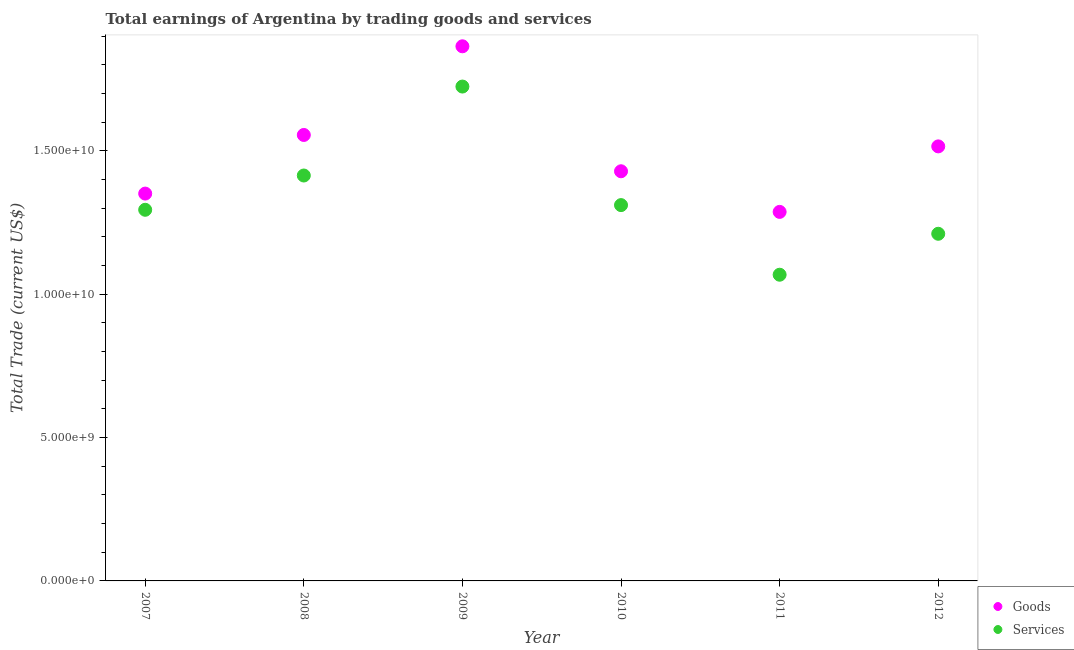How many different coloured dotlines are there?
Offer a very short reply. 2. Is the number of dotlines equal to the number of legend labels?
Offer a very short reply. Yes. What is the amount earned by trading goods in 2007?
Offer a terse response. 1.35e+1. Across all years, what is the maximum amount earned by trading goods?
Offer a terse response. 1.86e+1. Across all years, what is the minimum amount earned by trading services?
Provide a succinct answer. 1.07e+1. In which year was the amount earned by trading services maximum?
Make the answer very short. 2009. In which year was the amount earned by trading services minimum?
Ensure brevity in your answer.  2011. What is the total amount earned by trading goods in the graph?
Provide a succinct answer. 9.00e+1. What is the difference between the amount earned by trading goods in 2010 and that in 2012?
Provide a short and direct response. -8.68e+08. What is the difference between the amount earned by trading goods in 2012 and the amount earned by trading services in 2009?
Your answer should be very brief. -2.09e+09. What is the average amount earned by trading services per year?
Provide a succinct answer. 1.34e+1. In the year 2009, what is the difference between the amount earned by trading services and amount earned by trading goods?
Give a very brief answer. -1.40e+09. What is the ratio of the amount earned by trading services in 2008 to that in 2009?
Your answer should be very brief. 0.82. Is the difference between the amount earned by trading services in 2008 and 2009 greater than the difference between the amount earned by trading goods in 2008 and 2009?
Offer a very short reply. No. What is the difference between the highest and the second highest amount earned by trading services?
Ensure brevity in your answer.  3.10e+09. What is the difference between the highest and the lowest amount earned by trading goods?
Offer a terse response. 5.77e+09. Is the sum of the amount earned by trading services in 2010 and 2012 greater than the maximum amount earned by trading goods across all years?
Make the answer very short. Yes. Is the amount earned by trading goods strictly less than the amount earned by trading services over the years?
Your answer should be very brief. No. Are the values on the major ticks of Y-axis written in scientific E-notation?
Make the answer very short. Yes. Does the graph contain grids?
Your answer should be very brief. No. How many legend labels are there?
Give a very brief answer. 2. How are the legend labels stacked?
Ensure brevity in your answer.  Vertical. What is the title of the graph?
Provide a short and direct response. Total earnings of Argentina by trading goods and services. What is the label or title of the X-axis?
Give a very brief answer. Year. What is the label or title of the Y-axis?
Your response must be concise. Total Trade (current US$). What is the Total Trade (current US$) in Goods in 2007?
Offer a terse response. 1.35e+1. What is the Total Trade (current US$) in Services in 2007?
Your response must be concise. 1.29e+1. What is the Total Trade (current US$) in Goods in 2008?
Offer a terse response. 1.56e+1. What is the Total Trade (current US$) in Services in 2008?
Make the answer very short. 1.41e+1. What is the Total Trade (current US$) of Goods in 2009?
Offer a terse response. 1.86e+1. What is the Total Trade (current US$) of Services in 2009?
Give a very brief answer. 1.72e+1. What is the Total Trade (current US$) of Goods in 2010?
Your response must be concise. 1.43e+1. What is the Total Trade (current US$) of Services in 2010?
Keep it short and to the point. 1.31e+1. What is the Total Trade (current US$) of Goods in 2011?
Offer a terse response. 1.29e+1. What is the Total Trade (current US$) of Services in 2011?
Make the answer very short. 1.07e+1. What is the Total Trade (current US$) in Goods in 2012?
Keep it short and to the point. 1.52e+1. What is the Total Trade (current US$) of Services in 2012?
Your answer should be compact. 1.21e+1. Across all years, what is the maximum Total Trade (current US$) in Goods?
Make the answer very short. 1.86e+1. Across all years, what is the maximum Total Trade (current US$) in Services?
Make the answer very short. 1.72e+1. Across all years, what is the minimum Total Trade (current US$) in Goods?
Offer a terse response. 1.29e+1. Across all years, what is the minimum Total Trade (current US$) in Services?
Your answer should be compact. 1.07e+1. What is the total Total Trade (current US$) in Goods in the graph?
Ensure brevity in your answer.  9.00e+1. What is the total Total Trade (current US$) of Services in the graph?
Keep it short and to the point. 8.02e+1. What is the difference between the Total Trade (current US$) in Goods in 2007 and that in 2008?
Ensure brevity in your answer.  -2.04e+09. What is the difference between the Total Trade (current US$) in Services in 2007 and that in 2008?
Give a very brief answer. -1.20e+09. What is the difference between the Total Trade (current US$) of Goods in 2007 and that in 2009?
Offer a terse response. -5.14e+09. What is the difference between the Total Trade (current US$) of Services in 2007 and that in 2009?
Make the answer very short. -4.30e+09. What is the difference between the Total Trade (current US$) of Goods in 2007 and that in 2010?
Provide a succinct answer. -7.78e+08. What is the difference between the Total Trade (current US$) of Services in 2007 and that in 2010?
Make the answer very short. -1.63e+08. What is the difference between the Total Trade (current US$) of Goods in 2007 and that in 2011?
Ensure brevity in your answer.  6.38e+08. What is the difference between the Total Trade (current US$) of Services in 2007 and that in 2011?
Your response must be concise. 2.26e+09. What is the difference between the Total Trade (current US$) in Goods in 2007 and that in 2012?
Give a very brief answer. -1.65e+09. What is the difference between the Total Trade (current US$) in Services in 2007 and that in 2012?
Provide a succinct answer. 8.37e+08. What is the difference between the Total Trade (current US$) in Goods in 2008 and that in 2009?
Make the answer very short. -3.09e+09. What is the difference between the Total Trade (current US$) of Services in 2008 and that in 2009?
Keep it short and to the point. -3.10e+09. What is the difference between the Total Trade (current US$) of Goods in 2008 and that in 2010?
Make the answer very short. 1.27e+09. What is the difference between the Total Trade (current US$) of Services in 2008 and that in 2010?
Offer a terse response. 1.03e+09. What is the difference between the Total Trade (current US$) of Goods in 2008 and that in 2011?
Offer a terse response. 2.68e+09. What is the difference between the Total Trade (current US$) of Services in 2008 and that in 2011?
Offer a terse response. 3.46e+09. What is the difference between the Total Trade (current US$) of Goods in 2008 and that in 2012?
Ensure brevity in your answer.  3.98e+08. What is the difference between the Total Trade (current US$) in Services in 2008 and that in 2012?
Provide a short and direct response. 2.03e+09. What is the difference between the Total Trade (current US$) in Goods in 2009 and that in 2010?
Offer a very short reply. 4.36e+09. What is the difference between the Total Trade (current US$) in Services in 2009 and that in 2010?
Give a very brief answer. 4.13e+09. What is the difference between the Total Trade (current US$) in Goods in 2009 and that in 2011?
Ensure brevity in your answer.  5.77e+09. What is the difference between the Total Trade (current US$) of Services in 2009 and that in 2011?
Offer a very short reply. 6.56e+09. What is the difference between the Total Trade (current US$) of Goods in 2009 and that in 2012?
Offer a very short reply. 3.49e+09. What is the difference between the Total Trade (current US$) in Services in 2009 and that in 2012?
Ensure brevity in your answer.  5.13e+09. What is the difference between the Total Trade (current US$) of Goods in 2010 and that in 2011?
Offer a terse response. 1.42e+09. What is the difference between the Total Trade (current US$) in Services in 2010 and that in 2011?
Offer a very short reply. 2.43e+09. What is the difference between the Total Trade (current US$) in Goods in 2010 and that in 2012?
Ensure brevity in your answer.  -8.68e+08. What is the difference between the Total Trade (current US$) in Services in 2010 and that in 2012?
Offer a very short reply. 1.00e+09. What is the difference between the Total Trade (current US$) in Goods in 2011 and that in 2012?
Provide a succinct answer. -2.28e+09. What is the difference between the Total Trade (current US$) in Services in 2011 and that in 2012?
Your answer should be compact. -1.43e+09. What is the difference between the Total Trade (current US$) in Goods in 2007 and the Total Trade (current US$) in Services in 2008?
Your response must be concise. -6.30e+08. What is the difference between the Total Trade (current US$) in Goods in 2007 and the Total Trade (current US$) in Services in 2009?
Your answer should be very brief. -3.73e+09. What is the difference between the Total Trade (current US$) of Goods in 2007 and the Total Trade (current US$) of Services in 2010?
Offer a very short reply. 4.02e+08. What is the difference between the Total Trade (current US$) of Goods in 2007 and the Total Trade (current US$) of Services in 2011?
Your answer should be compact. 2.83e+09. What is the difference between the Total Trade (current US$) of Goods in 2007 and the Total Trade (current US$) of Services in 2012?
Offer a very short reply. 1.40e+09. What is the difference between the Total Trade (current US$) of Goods in 2008 and the Total Trade (current US$) of Services in 2009?
Offer a very short reply. -1.69e+09. What is the difference between the Total Trade (current US$) in Goods in 2008 and the Total Trade (current US$) in Services in 2010?
Keep it short and to the point. 2.45e+09. What is the difference between the Total Trade (current US$) of Goods in 2008 and the Total Trade (current US$) of Services in 2011?
Provide a succinct answer. 4.87e+09. What is the difference between the Total Trade (current US$) of Goods in 2008 and the Total Trade (current US$) of Services in 2012?
Ensure brevity in your answer.  3.45e+09. What is the difference between the Total Trade (current US$) of Goods in 2009 and the Total Trade (current US$) of Services in 2010?
Make the answer very short. 5.54e+09. What is the difference between the Total Trade (current US$) of Goods in 2009 and the Total Trade (current US$) of Services in 2011?
Provide a short and direct response. 7.97e+09. What is the difference between the Total Trade (current US$) of Goods in 2009 and the Total Trade (current US$) of Services in 2012?
Make the answer very short. 6.54e+09. What is the difference between the Total Trade (current US$) of Goods in 2010 and the Total Trade (current US$) of Services in 2011?
Ensure brevity in your answer.  3.61e+09. What is the difference between the Total Trade (current US$) in Goods in 2010 and the Total Trade (current US$) in Services in 2012?
Offer a very short reply. 2.18e+09. What is the difference between the Total Trade (current US$) of Goods in 2011 and the Total Trade (current US$) of Services in 2012?
Provide a succinct answer. 7.63e+08. What is the average Total Trade (current US$) in Goods per year?
Make the answer very short. 1.50e+1. What is the average Total Trade (current US$) of Services per year?
Your answer should be compact. 1.34e+1. In the year 2007, what is the difference between the Total Trade (current US$) in Goods and Total Trade (current US$) in Services?
Your response must be concise. 5.65e+08. In the year 2008, what is the difference between the Total Trade (current US$) in Goods and Total Trade (current US$) in Services?
Your answer should be compact. 1.41e+09. In the year 2009, what is the difference between the Total Trade (current US$) of Goods and Total Trade (current US$) of Services?
Keep it short and to the point. 1.40e+09. In the year 2010, what is the difference between the Total Trade (current US$) in Goods and Total Trade (current US$) in Services?
Ensure brevity in your answer.  1.18e+09. In the year 2011, what is the difference between the Total Trade (current US$) in Goods and Total Trade (current US$) in Services?
Your response must be concise. 2.19e+09. In the year 2012, what is the difference between the Total Trade (current US$) of Goods and Total Trade (current US$) of Services?
Offer a very short reply. 3.05e+09. What is the ratio of the Total Trade (current US$) in Goods in 2007 to that in 2008?
Offer a very short reply. 0.87. What is the ratio of the Total Trade (current US$) in Services in 2007 to that in 2008?
Offer a very short reply. 0.92. What is the ratio of the Total Trade (current US$) of Goods in 2007 to that in 2009?
Provide a short and direct response. 0.72. What is the ratio of the Total Trade (current US$) in Services in 2007 to that in 2009?
Your answer should be very brief. 0.75. What is the ratio of the Total Trade (current US$) in Goods in 2007 to that in 2010?
Provide a short and direct response. 0.95. What is the ratio of the Total Trade (current US$) in Services in 2007 to that in 2010?
Your answer should be very brief. 0.99. What is the ratio of the Total Trade (current US$) in Goods in 2007 to that in 2011?
Provide a succinct answer. 1.05. What is the ratio of the Total Trade (current US$) in Services in 2007 to that in 2011?
Give a very brief answer. 1.21. What is the ratio of the Total Trade (current US$) in Goods in 2007 to that in 2012?
Offer a terse response. 0.89. What is the ratio of the Total Trade (current US$) in Services in 2007 to that in 2012?
Provide a short and direct response. 1.07. What is the ratio of the Total Trade (current US$) in Goods in 2008 to that in 2009?
Give a very brief answer. 0.83. What is the ratio of the Total Trade (current US$) of Services in 2008 to that in 2009?
Provide a short and direct response. 0.82. What is the ratio of the Total Trade (current US$) in Goods in 2008 to that in 2010?
Offer a terse response. 1.09. What is the ratio of the Total Trade (current US$) of Services in 2008 to that in 2010?
Provide a short and direct response. 1.08. What is the ratio of the Total Trade (current US$) in Goods in 2008 to that in 2011?
Your answer should be compact. 1.21. What is the ratio of the Total Trade (current US$) of Services in 2008 to that in 2011?
Offer a very short reply. 1.32. What is the ratio of the Total Trade (current US$) of Goods in 2008 to that in 2012?
Offer a very short reply. 1.03. What is the ratio of the Total Trade (current US$) of Services in 2008 to that in 2012?
Provide a short and direct response. 1.17. What is the ratio of the Total Trade (current US$) in Goods in 2009 to that in 2010?
Make the answer very short. 1.31. What is the ratio of the Total Trade (current US$) of Services in 2009 to that in 2010?
Ensure brevity in your answer.  1.32. What is the ratio of the Total Trade (current US$) of Goods in 2009 to that in 2011?
Provide a short and direct response. 1.45. What is the ratio of the Total Trade (current US$) of Services in 2009 to that in 2011?
Ensure brevity in your answer.  1.61. What is the ratio of the Total Trade (current US$) of Goods in 2009 to that in 2012?
Make the answer very short. 1.23. What is the ratio of the Total Trade (current US$) of Services in 2009 to that in 2012?
Ensure brevity in your answer.  1.42. What is the ratio of the Total Trade (current US$) in Goods in 2010 to that in 2011?
Your answer should be very brief. 1.11. What is the ratio of the Total Trade (current US$) of Services in 2010 to that in 2011?
Give a very brief answer. 1.23. What is the ratio of the Total Trade (current US$) of Goods in 2010 to that in 2012?
Offer a terse response. 0.94. What is the ratio of the Total Trade (current US$) in Services in 2010 to that in 2012?
Provide a succinct answer. 1.08. What is the ratio of the Total Trade (current US$) of Goods in 2011 to that in 2012?
Keep it short and to the point. 0.85. What is the ratio of the Total Trade (current US$) in Services in 2011 to that in 2012?
Give a very brief answer. 0.88. What is the difference between the highest and the second highest Total Trade (current US$) of Goods?
Make the answer very short. 3.09e+09. What is the difference between the highest and the second highest Total Trade (current US$) in Services?
Your answer should be very brief. 3.10e+09. What is the difference between the highest and the lowest Total Trade (current US$) of Goods?
Your response must be concise. 5.77e+09. What is the difference between the highest and the lowest Total Trade (current US$) of Services?
Offer a very short reply. 6.56e+09. 